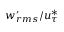Convert formula to latex. <formula><loc_0><loc_0><loc_500><loc_500>w _ { r m s } ^ { \prime } / u _ { \tau } ^ { * }</formula> 